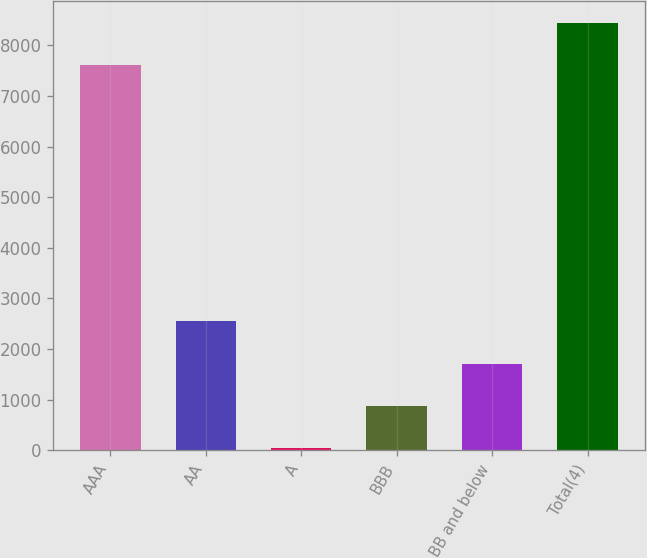Convert chart. <chart><loc_0><loc_0><loc_500><loc_500><bar_chart><fcel>AAA<fcel>AA<fcel>A<fcel>BBB<fcel>BB and below<fcel>Total(4)<nl><fcel>7613<fcel>2544.7<fcel>40<fcel>874.9<fcel>1709.8<fcel>8447.9<nl></chart> 